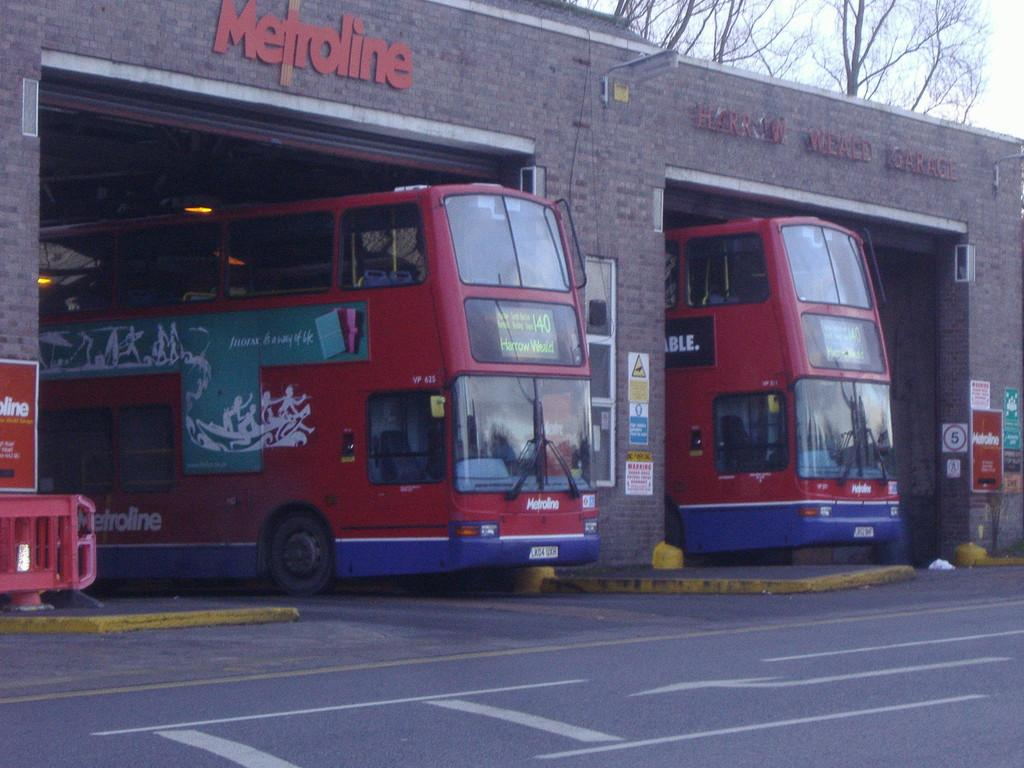What is located in the middle of the image? There are buses, posters, a house, text, a light, and a wall in the middle of the image. What type of transportation can be seen in the image? There are buses in the middle of the image. What is the background of the image? There are trees and sky visible at the top of the image. What is at the bottom of the image? There is a road at the bottom of the image. Can you see any boats in the image? No, there are no boats present in the image. Is there a pancake visible in the image? No, there is no pancake present in the image. 